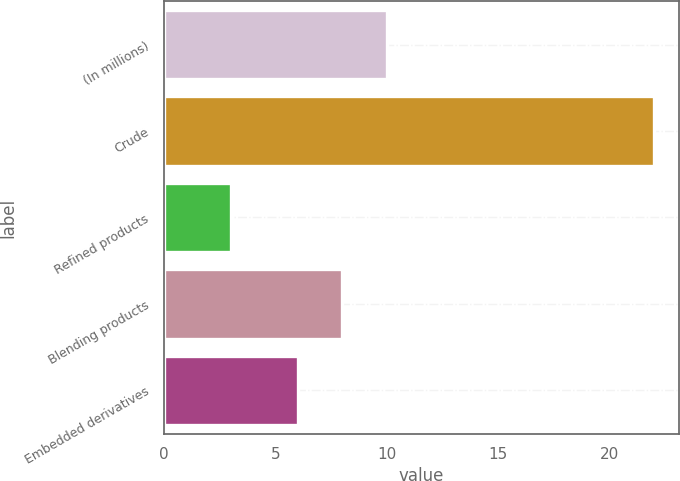Convert chart. <chart><loc_0><loc_0><loc_500><loc_500><bar_chart><fcel>(In millions)<fcel>Crude<fcel>Refined products<fcel>Blending products<fcel>Embedded derivatives<nl><fcel>10<fcel>22<fcel>3<fcel>8<fcel>6<nl></chart> 